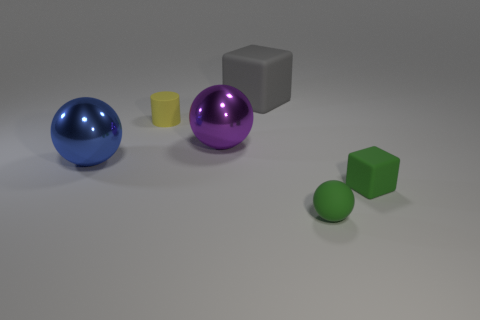Are the big thing in front of the purple ball and the gray thing made of the same material?
Make the answer very short. No. There is a sphere in front of the metal sphere left of the big purple shiny object; what is its material?
Your response must be concise. Rubber. Are there more small yellow cylinders that are in front of the gray thing than green matte cubes that are behind the tiny yellow thing?
Provide a succinct answer. Yes. What size is the purple sphere?
Your answer should be very brief. Large. There is a matte block in front of the large blue object; does it have the same color as the tiny sphere?
Your answer should be very brief. Yes. Are there any other things that are the same shape as the yellow thing?
Keep it short and to the point. No. Is there a big cube on the left side of the large thing to the right of the purple object?
Offer a very short reply. No. Is the number of small blocks that are left of the small ball less than the number of small yellow cylinders that are to the left of the large block?
Offer a very short reply. Yes. There is a block behind the small block that is right of the big blue thing behind the small rubber cube; how big is it?
Offer a very short reply. Large. There is a rubber cube to the right of the gray object; is it the same size as the large blue shiny sphere?
Give a very brief answer. No. 